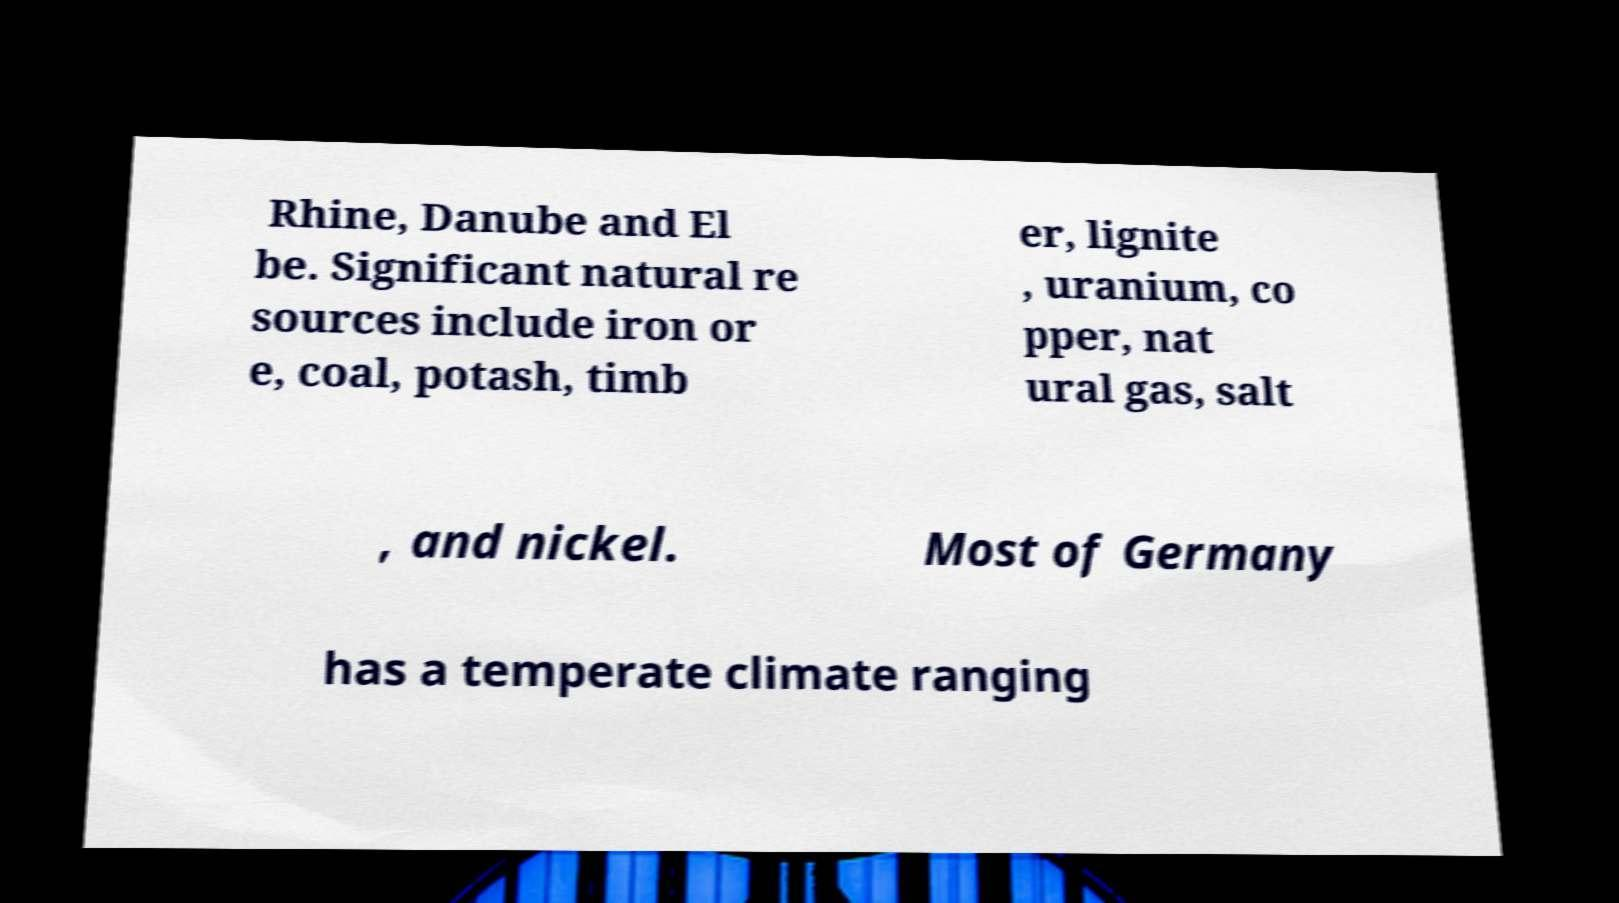For documentation purposes, I need the text within this image transcribed. Could you provide that? Rhine, Danube and El be. Significant natural re sources include iron or e, coal, potash, timb er, lignite , uranium, co pper, nat ural gas, salt , and nickel. Most of Germany has a temperate climate ranging 